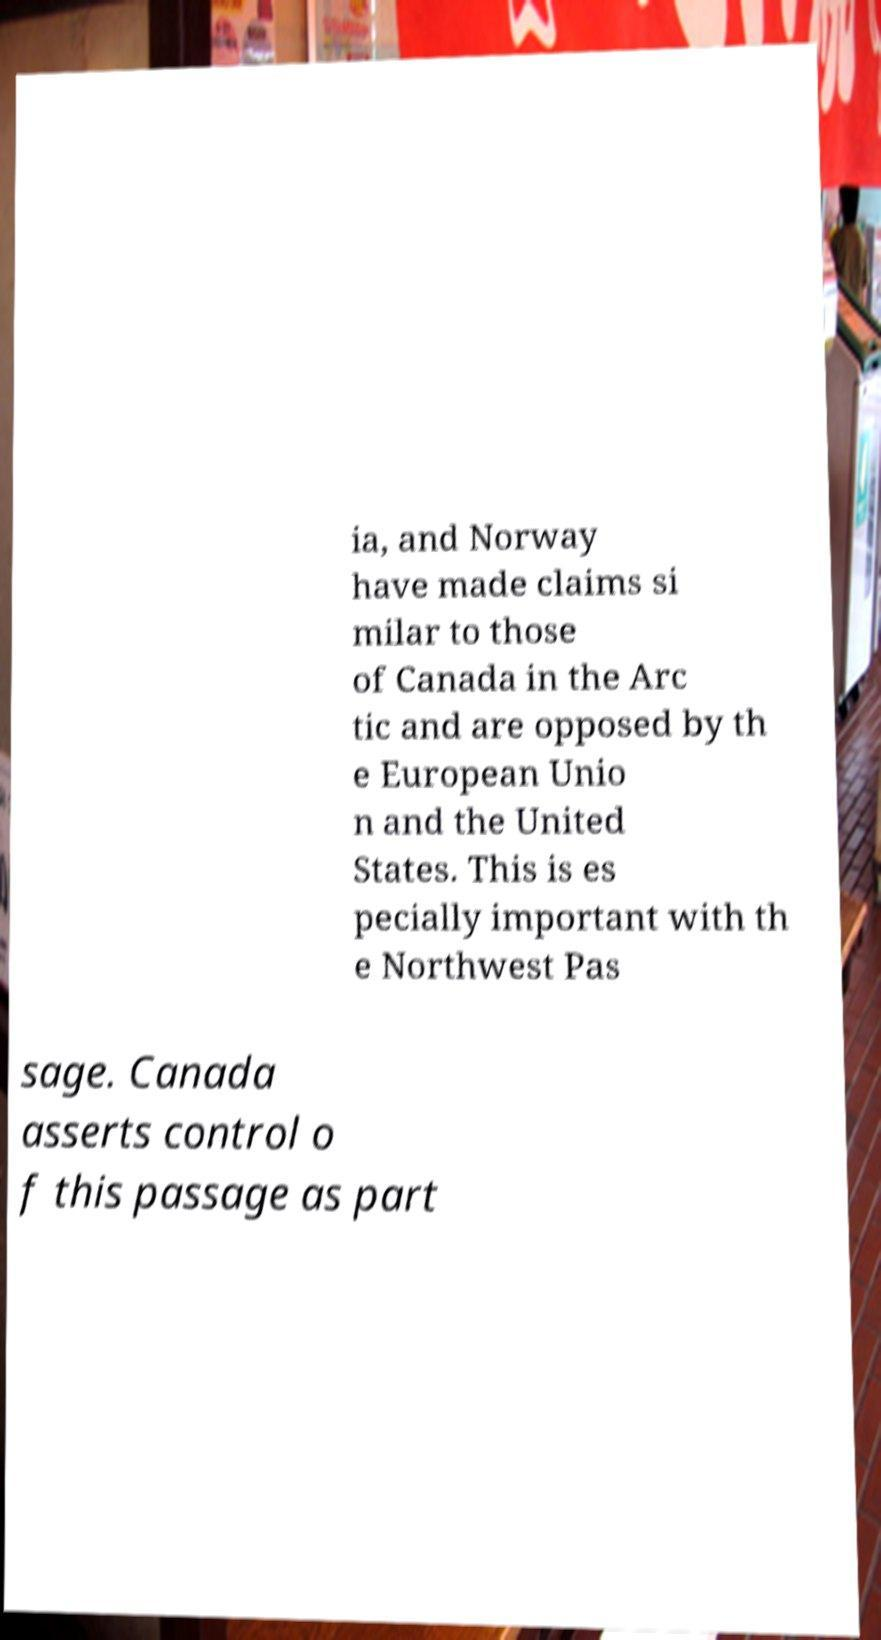Please identify and transcribe the text found in this image. ia, and Norway have made claims si milar to those of Canada in the Arc tic and are opposed by th e European Unio n and the United States. This is es pecially important with th e Northwest Pas sage. Canada asserts control o f this passage as part 